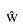<formula> <loc_0><loc_0><loc_500><loc_500>\hat { w }</formula> 